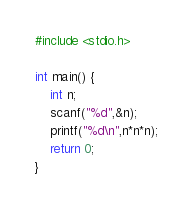Convert code to text. <code><loc_0><loc_0><loc_500><loc_500><_C_>#include <stdio.h>

int main() {
    int n;
    scanf("%d",&n);
    printf("%d\n",n*n*n);
    return 0;
}</code> 